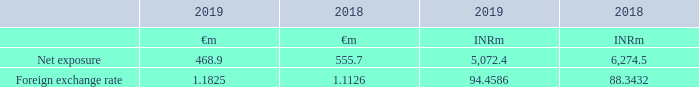27 Financial risk management (continued)
The table below summarises the Group’s exposure to foreign exchange risk as well as the foreign exchange rates applied:
The approximate impact of a 10 per cent appreciation in foreign exchange rates would be a positive movement of £50.0 million (2018: £63.4 million) to equity attributable to owners of the Group. The approximate impact of a 10 per cent depreciation in foreign exchange rates would be a negative movement of £40.9 million (2018: £51.9 million) to equity attributable to owners of the Group. There is no material income statement impact as these exchange differences are recognised in other comprehensive income.
As part of the strategy to mitigate the Group’s exposure to foreign exchange risk, the Group is able to borrow part of its RCF in euros, up to €100 million. The RCF borrowings denominated in euros have been designated as a hedging instrument (net investment hedge) against the Group’s net investment in Spain with the hedged risk being the changes in the euro/pounds sterling spot rate that will result in changes in the value of the Group’s net investments in Spain. At 31 December 2019, €100 million (2018: €100 million) was drawn in euros.
What is the net exposure to foreign exchange risk (euro) in 2019?
Answer scale should be: million. 468.9. What is the net exposure to foreign exchange risk (indian rupee) in 2018?
Answer scale should be: million. 6,274.5. What is the net exposure to foreign exchange risk (euro) in 2018?
Answer scale should be: million. 555.7. What is the change in the positive movement of money to equity attributable to owners of the Group when there is a 10 per cent appreciation in foreign exchange rates from 2018 to 2019?
Answer scale should be: million. 50.0-63.4
Answer: -13.4. What is the change in the negative movement of money to equity attributable to owners of the Group when there is a 10 per cent depreciation in foreign exchange rates from 2018 to 2019?
Answer scale should be: million. 40.9-51.9
Answer: -11. What is the percentage change in the amount drawn in euros from 2018 to 2019?
Answer scale should be: percent. (100-100)/100
Answer: 0. 